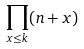Convert formula to latex. <formula><loc_0><loc_0><loc_500><loc_500>\prod _ { x \leq k } ( n + x )</formula> 